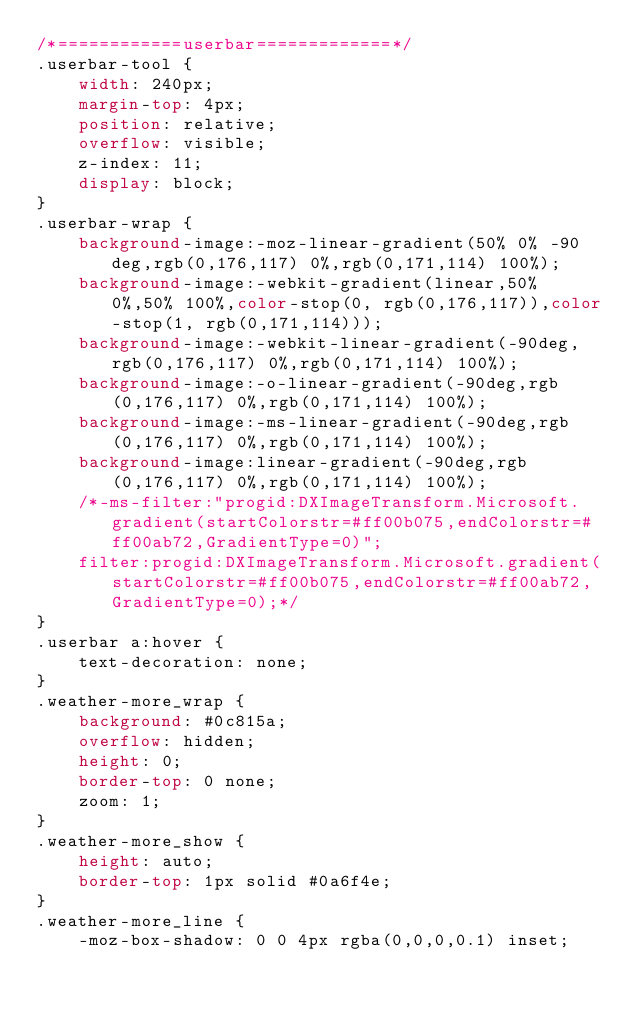Convert code to text. <code><loc_0><loc_0><loc_500><loc_500><_CSS_>/*============userbar=============*/
.userbar-tool {
    width: 240px;
    margin-top: 4px;
    position: relative;
    overflow: visible;
    z-index: 11;
    display: block;
}
.userbar-wrap {
    background-image:-moz-linear-gradient(50% 0% -90deg,rgb(0,176,117) 0%,rgb(0,171,114) 100%); 
    background-image:-webkit-gradient(linear,50% 0%,50% 100%,color-stop(0, rgb(0,176,117)),color-stop(1, rgb(0,171,114)));
    background-image:-webkit-linear-gradient(-90deg,rgb(0,176,117) 0%,rgb(0,171,114) 100%);
    background-image:-o-linear-gradient(-90deg,rgb(0,176,117) 0%,rgb(0,171,114) 100%);
    background-image:-ms-linear-gradient(-90deg,rgb(0,176,117) 0%,rgb(0,171,114) 100%);
    background-image:linear-gradient(-90deg,rgb(0,176,117) 0%,rgb(0,171,114) 100%);
    /*-ms-filter:"progid:DXImageTransform.Microsoft.gradient(startColorstr=#ff00b075,endColorstr=#ff00ab72,GradientType=0)";
    filter:progid:DXImageTransform.Microsoft.gradient(startColorstr=#ff00b075,endColorstr=#ff00ab72,GradientType=0);*/
}
.userbar a:hover {
    text-decoration: none;
}
.weather-more_wrap {
    background: #0c815a;
    overflow: hidden;
    height: 0;
    border-top: 0 none;
    zoom: 1;
}
.weather-more_show {
    height: auto;
    border-top: 1px solid #0a6f4e;
}
.weather-more_line {
    -moz-box-shadow: 0 0 4px rgba(0,0,0,0.1) inset;</code> 